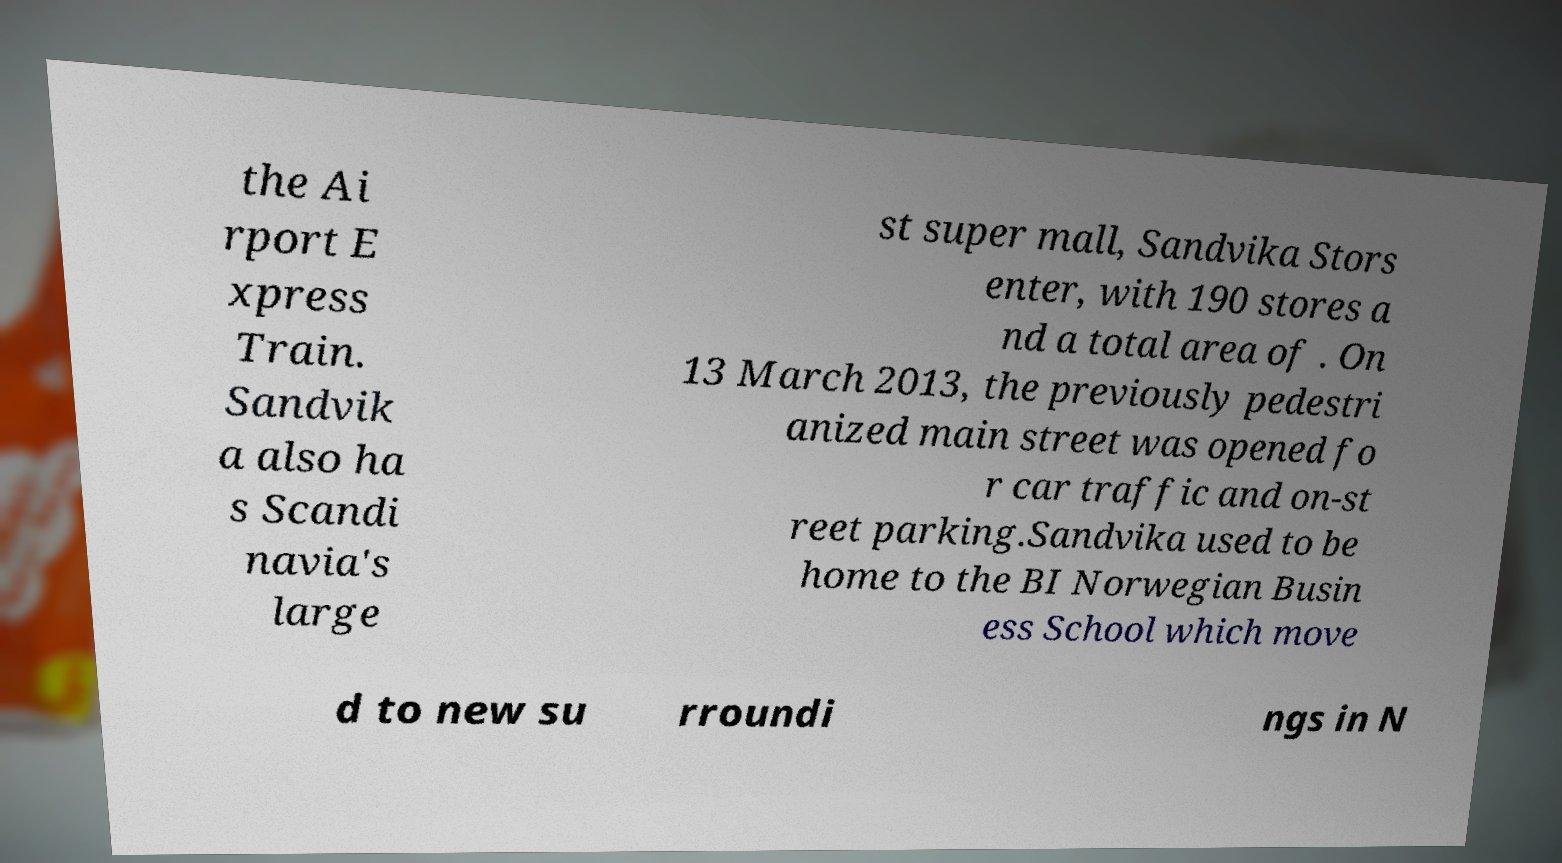There's text embedded in this image that I need extracted. Can you transcribe it verbatim? the Ai rport E xpress Train. Sandvik a also ha s Scandi navia's large st super mall, Sandvika Stors enter, with 190 stores a nd a total area of . On 13 March 2013, the previously pedestri anized main street was opened fo r car traffic and on-st reet parking.Sandvika used to be home to the BI Norwegian Busin ess School which move d to new su rroundi ngs in N 